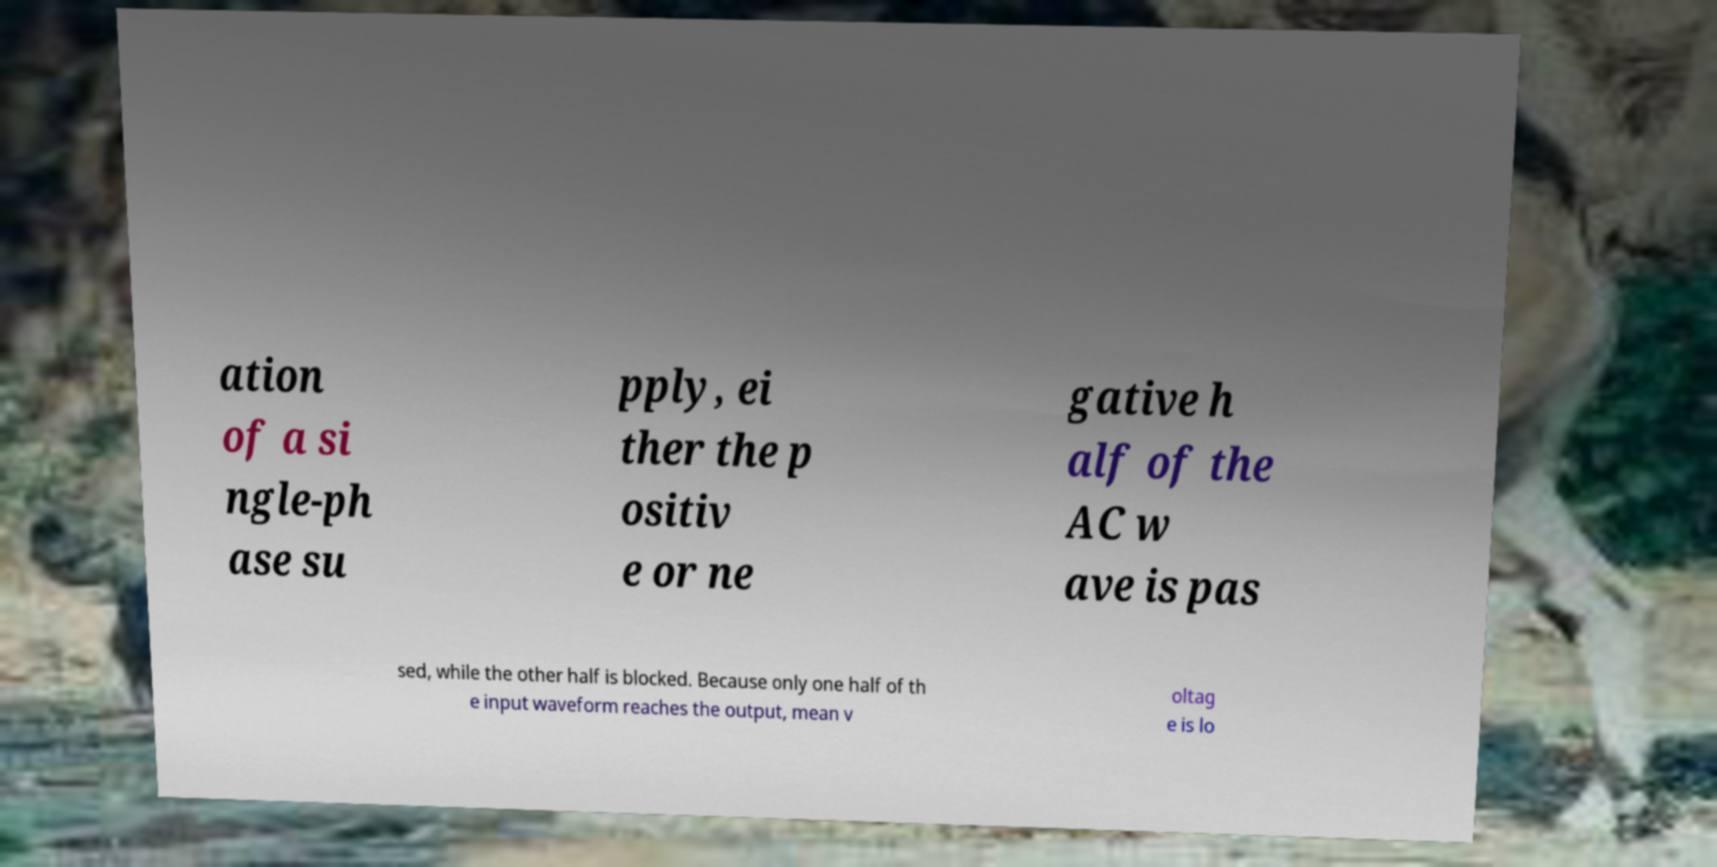Can you accurately transcribe the text from the provided image for me? ation of a si ngle-ph ase su pply, ei ther the p ositiv e or ne gative h alf of the AC w ave is pas sed, while the other half is blocked. Because only one half of th e input waveform reaches the output, mean v oltag e is lo 